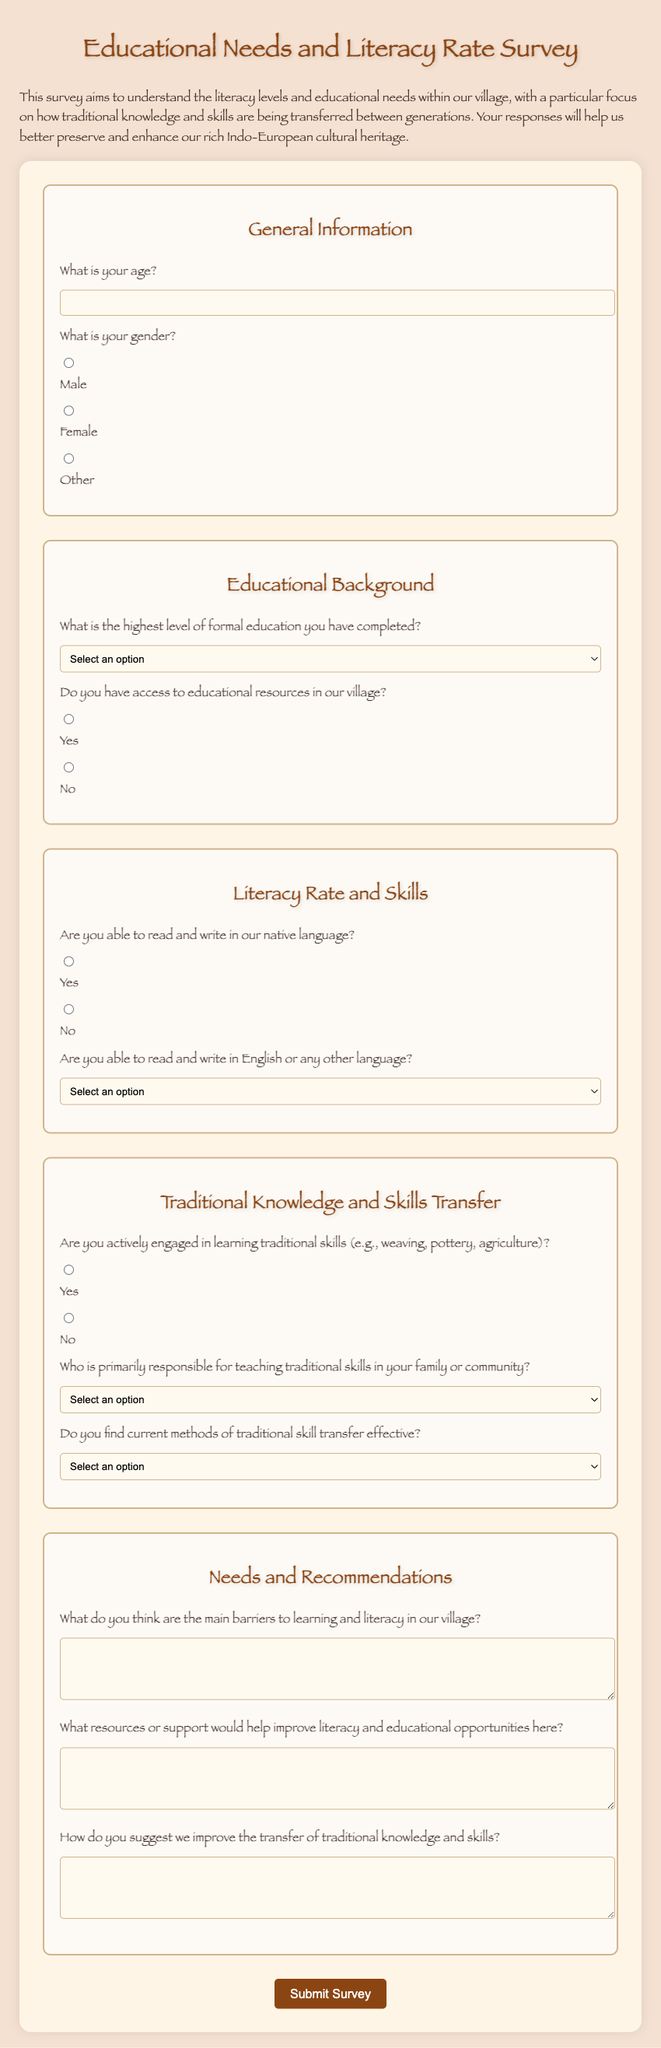What is the title of the survey? The title is prominently displayed at the top of the document indicating the focus of the survey.
Answer: Educational Needs and Literacy Rate Survey What is the main purpose of the survey? The introductory paragraph outlines the aim of the survey in terms of literacy levels and educational needs.
Answer: To understand literacy levels and educational needs What is the maximum age input allowed in the form? The form provides a field for age input which typically allows a range but does not specify a maximum age limit.
Answer: Not specified How many traditional skills categories are mentioned? The section on traditional skills mentions at least one specific type of skill as an example.
Answer: Three (weaving, pottery, agriculture) Who are the potential teachers of traditional skills according to the options given? The document provides a select list of individuals responsible for teaching traditional skills in the community.
Answer: Parents, Grandparents, Community elders, Local school What method is suggested for gathering information about barriers to learning? The survey provides a text area specifically for participants to articulate their thoughts regarding obstacles to learning.
Answer: Open-ended text area What is the color of the button to submit the survey? The style section indicates the button's background color when hovered over and when not.
Answer: Brown How many sections are there in the survey form? The form includes distinct areas to structure the information collected from participants.
Answer: Five sections 